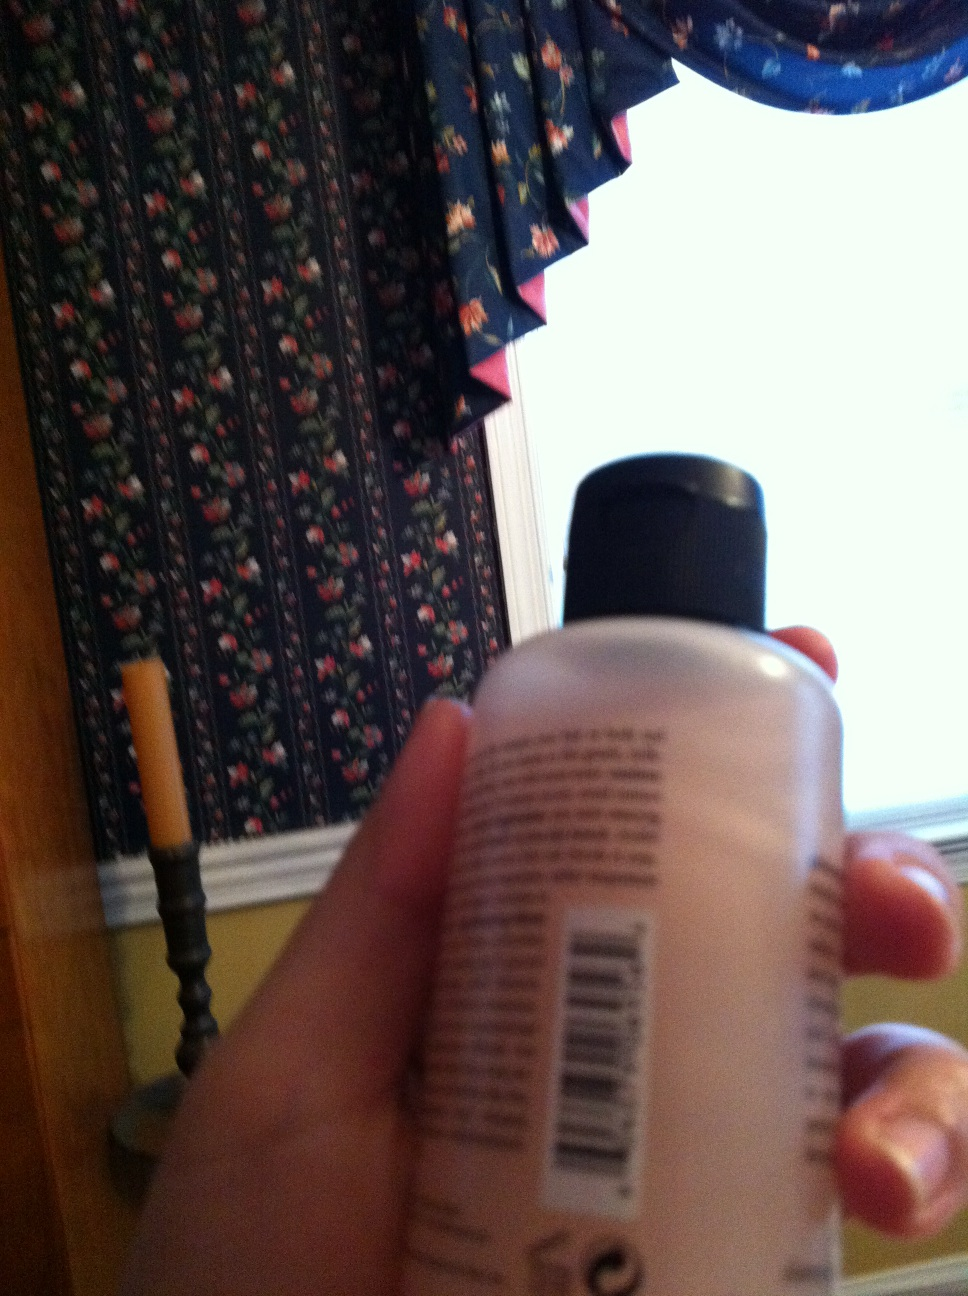Describe a casual but engaging response regarding the blurred text on the bottle. The text on the bottle is too blurry to make out, but it looks like it includes the usual stuff you'd find on a skincare product—maybe some usage directions, ingredients, and brand information. It’s probably something simple like a moisturizer or lotion. 